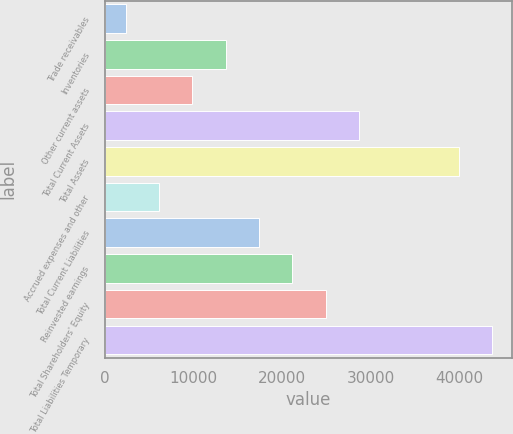Convert chart to OTSL. <chart><loc_0><loc_0><loc_500><loc_500><bar_chart><fcel>Trade receivables<fcel>Inventories<fcel>Other current assets<fcel>Total Current Assets<fcel>Total Assets<fcel>Accrued expenses and other<fcel>Total Current Liabilities<fcel>Reinvested earnings<fcel>Total Shareholders' Equity<fcel>Total Liabilities Temporary<nl><fcel>2343<fcel>13626.9<fcel>9865.6<fcel>28672.1<fcel>39956<fcel>6104.3<fcel>17388.2<fcel>21149.5<fcel>24910.8<fcel>43717.3<nl></chart> 